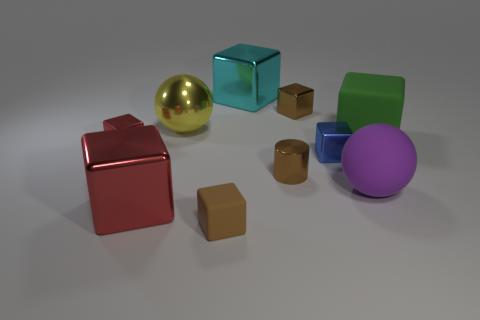How big is the metallic block that is both behind the big rubber ball and on the left side of the cyan metal block?
Keep it short and to the point. Small. Are there any other yellow balls that have the same material as the yellow ball?
Provide a succinct answer. No. There is a metallic cube that is the same color as the tiny cylinder; what size is it?
Your response must be concise. Small. There is a yellow sphere to the left of the tiny shiny cube that is behind the big yellow metallic sphere; what is its material?
Give a very brief answer. Metal. How many rubber blocks have the same color as the large matte sphere?
Offer a very short reply. 0. What size is the blue cube that is the same material as the big red cube?
Make the answer very short. Small. What is the shape of the red metal thing that is to the left of the big red metal object?
Give a very brief answer. Cube. What size is the purple thing that is the same shape as the yellow thing?
Your answer should be very brief. Large. How many brown rubber blocks are behind the small brown metal object on the right side of the brown shiny cylinder that is to the right of the brown rubber thing?
Keep it short and to the point. 0. Are there the same number of green blocks that are behind the tiny blue shiny thing and tiny blue metal cylinders?
Offer a very short reply. No. 